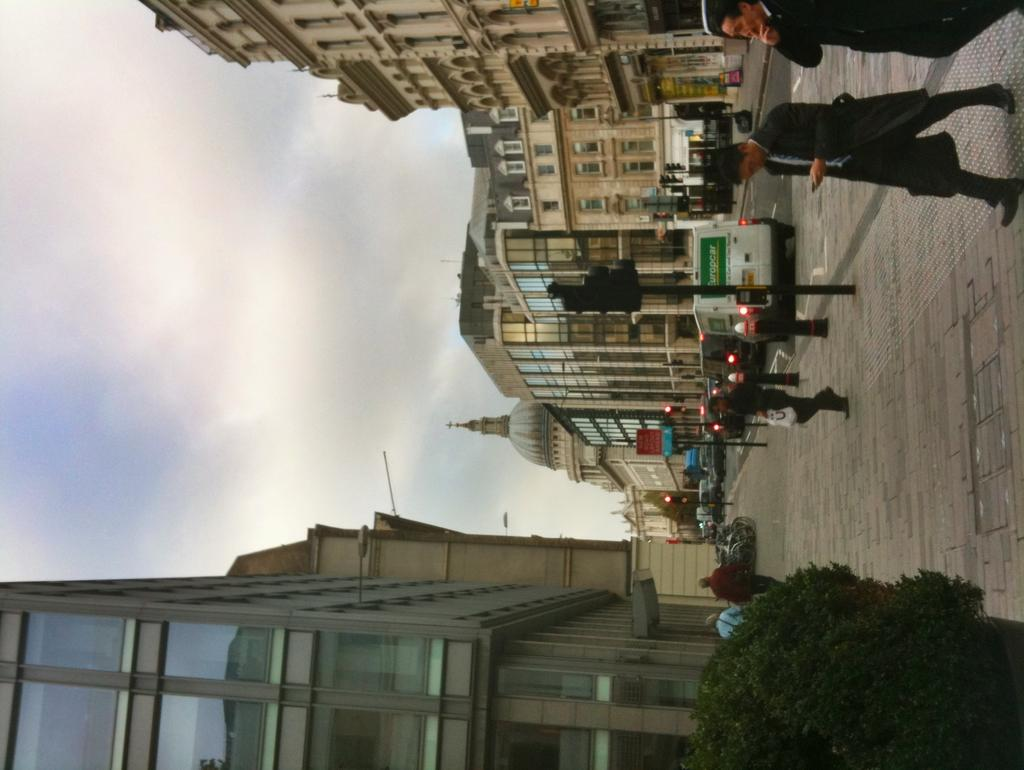What type of living organism can be seen in the bottom right corner of the image? There is a plant in the bottom right corner of the image. Can you describe the people visible in the image? There are persons visible in the image, but their specific characteristics are not mentioned in the facts. What type of structures are on the right side of the image? There are buildings on the right side of the image. What part of the natural environment is visible in the image? The sky is visible on the left side of the image. How does the giraffe compare to the plant in the image? There is no giraffe present in the image, so it cannot be compared to the plant. 